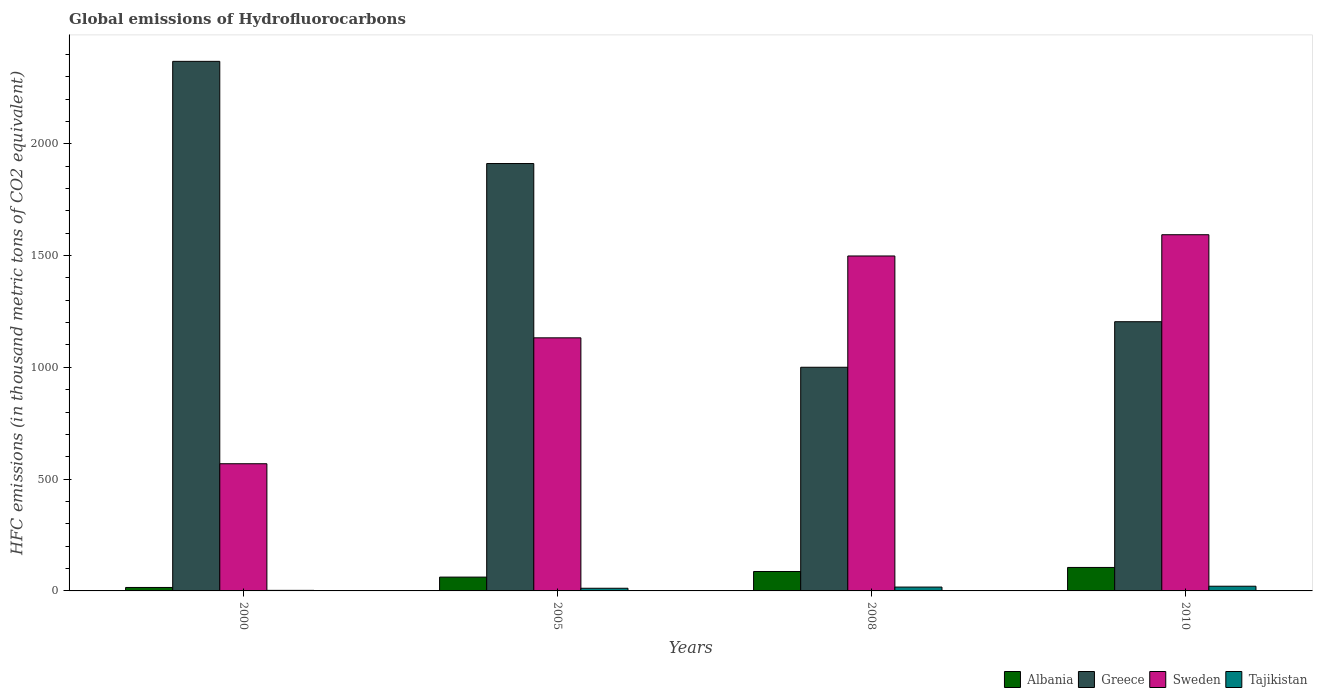Are the number of bars per tick equal to the number of legend labels?
Make the answer very short. Yes. How many bars are there on the 4th tick from the left?
Provide a succinct answer. 4. How many bars are there on the 3rd tick from the right?
Make the answer very short. 4. In how many cases, is the number of bars for a given year not equal to the number of legend labels?
Keep it short and to the point. 0. What is the global emissions of Hydrofluorocarbons in Greece in 2010?
Give a very brief answer. 1204. Across all years, what is the minimum global emissions of Hydrofluorocarbons in Albania?
Keep it short and to the point. 15.5. In which year was the global emissions of Hydrofluorocarbons in Greece maximum?
Your answer should be compact. 2000. In which year was the global emissions of Hydrofluorocarbons in Greece minimum?
Keep it short and to the point. 2008. What is the total global emissions of Hydrofluorocarbons in Greece in the graph?
Give a very brief answer. 6484.1. What is the difference between the global emissions of Hydrofluorocarbons in Albania in 2000 and that in 2005?
Offer a very short reply. -46.3. What is the difference between the global emissions of Hydrofluorocarbons in Greece in 2000 and the global emissions of Hydrofluorocarbons in Sweden in 2005?
Provide a short and direct response. 1236.5. What is the average global emissions of Hydrofluorocarbons in Tajikistan per year?
Give a very brief answer. 13.15. In the year 2000, what is the difference between the global emissions of Hydrofluorocarbons in Sweden and global emissions of Hydrofluorocarbons in Tajikistan?
Offer a terse response. 566.3. In how many years, is the global emissions of Hydrofluorocarbons in Tajikistan greater than 1100 thousand metric tons?
Ensure brevity in your answer.  0. What is the ratio of the global emissions of Hydrofluorocarbons in Albania in 2008 to that in 2010?
Give a very brief answer. 0.83. Is the global emissions of Hydrofluorocarbons in Greece in 2005 less than that in 2010?
Provide a short and direct response. No. What is the difference between the highest and the second highest global emissions of Hydrofluorocarbons in Sweden?
Your answer should be very brief. 95. What is the difference between the highest and the lowest global emissions of Hydrofluorocarbons in Greece?
Provide a short and direct response. 1368.1. Is the sum of the global emissions of Hydrofluorocarbons in Albania in 2005 and 2010 greater than the maximum global emissions of Hydrofluorocarbons in Tajikistan across all years?
Provide a succinct answer. Yes. What does the 4th bar from the left in 2005 represents?
Provide a succinct answer. Tajikistan. What does the 1st bar from the right in 2010 represents?
Your response must be concise. Tajikistan. Is it the case that in every year, the sum of the global emissions of Hydrofluorocarbons in Albania and global emissions of Hydrofluorocarbons in Tajikistan is greater than the global emissions of Hydrofluorocarbons in Greece?
Offer a very short reply. No. How many bars are there?
Keep it short and to the point. 16. Are all the bars in the graph horizontal?
Your answer should be compact. No. Are the values on the major ticks of Y-axis written in scientific E-notation?
Your response must be concise. No. Does the graph contain any zero values?
Ensure brevity in your answer.  No. Does the graph contain grids?
Give a very brief answer. No. Where does the legend appear in the graph?
Your answer should be compact. Bottom right. What is the title of the graph?
Provide a short and direct response. Global emissions of Hydrofluorocarbons. Does "Sao Tome and Principe" appear as one of the legend labels in the graph?
Give a very brief answer. No. What is the label or title of the Y-axis?
Your answer should be very brief. HFC emissions (in thousand metric tons of CO2 equivalent). What is the HFC emissions (in thousand metric tons of CO2 equivalent) in Greece in 2000?
Keep it short and to the point. 2368.4. What is the HFC emissions (in thousand metric tons of CO2 equivalent) of Sweden in 2000?
Offer a terse response. 568.8. What is the HFC emissions (in thousand metric tons of CO2 equivalent) in Albania in 2005?
Offer a very short reply. 61.8. What is the HFC emissions (in thousand metric tons of CO2 equivalent) of Greece in 2005?
Provide a succinct answer. 1911.4. What is the HFC emissions (in thousand metric tons of CO2 equivalent) of Sweden in 2005?
Your answer should be compact. 1131.9. What is the HFC emissions (in thousand metric tons of CO2 equivalent) in Albania in 2008?
Offer a very short reply. 86.9. What is the HFC emissions (in thousand metric tons of CO2 equivalent) of Greece in 2008?
Provide a succinct answer. 1000.3. What is the HFC emissions (in thousand metric tons of CO2 equivalent) in Sweden in 2008?
Your response must be concise. 1498. What is the HFC emissions (in thousand metric tons of CO2 equivalent) of Albania in 2010?
Provide a short and direct response. 105. What is the HFC emissions (in thousand metric tons of CO2 equivalent) in Greece in 2010?
Your answer should be compact. 1204. What is the HFC emissions (in thousand metric tons of CO2 equivalent) in Sweden in 2010?
Your answer should be compact. 1593. Across all years, what is the maximum HFC emissions (in thousand metric tons of CO2 equivalent) in Albania?
Provide a succinct answer. 105. Across all years, what is the maximum HFC emissions (in thousand metric tons of CO2 equivalent) of Greece?
Provide a succinct answer. 2368.4. Across all years, what is the maximum HFC emissions (in thousand metric tons of CO2 equivalent) of Sweden?
Keep it short and to the point. 1593. Across all years, what is the minimum HFC emissions (in thousand metric tons of CO2 equivalent) of Albania?
Make the answer very short. 15.5. Across all years, what is the minimum HFC emissions (in thousand metric tons of CO2 equivalent) of Greece?
Make the answer very short. 1000.3. Across all years, what is the minimum HFC emissions (in thousand metric tons of CO2 equivalent) in Sweden?
Give a very brief answer. 568.8. Across all years, what is the minimum HFC emissions (in thousand metric tons of CO2 equivalent) of Tajikistan?
Ensure brevity in your answer.  2.5. What is the total HFC emissions (in thousand metric tons of CO2 equivalent) in Albania in the graph?
Provide a short and direct response. 269.2. What is the total HFC emissions (in thousand metric tons of CO2 equivalent) in Greece in the graph?
Your answer should be compact. 6484.1. What is the total HFC emissions (in thousand metric tons of CO2 equivalent) of Sweden in the graph?
Offer a terse response. 4791.7. What is the total HFC emissions (in thousand metric tons of CO2 equivalent) of Tajikistan in the graph?
Provide a short and direct response. 52.6. What is the difference between the HFC emissions (in thousand metric tons of CO2 equivalent) in Albania in 2000 and that in 2005?
Make the answer very short. -46.3. What is the difference between the HFC emissions (in thousand metric tons of CO2 equivalent) of Greece in 2000 and that in 2005?
Your response must be concise. 457. What is the difference between the HFC emissions (in thousand metric tons of CO2 equivalent) in Sweden in 2000 and that in 2005?
Your answer should be very brief. -563.1. What is the difference between the HFC emissions (in thousand metric tons of CO2 equivalent) of Tajikistan in 2000 and that in 2005?
Provide a succinct answer. -9.4. What is the difference between the HFC emissions (in thousand metric tons of CO2 equivalent) of Albania in 2000 and that in 2008?
Make the answer very short. -71.4. What is the difference between the HFC emissions (in thousand metric tons of CO2 equivalent) in Greece in 2000 and that in 2008?
Make the answer very short. 1368.1. What is the difference between the HFC emissions (in thousand metric tons of CO2 equivalent) of Sweden in 2000 and that in 2008?
Offer a terse response. -929.2. What is the difference between the HFC emissions (in thousand metric tons of CO2 equivalent) of Tajikistan in 2000 and that in 2008?
Offer a very short reply. -14.7. What is the difference between the HFC emissions (in thousand metric tons of CO2 equivalent) of Albania in 2000 and that in 2010?
Offer a terse response. -89.5. What is the difference between the HFC emissions (in thousand metric tons of CO2 equivalent) in Greece in 2000 and that in 2010?
Your answer should be compact. 1164.4. What is the difference between the HFC emissions (in thousand metric tons of CO2 equivalent) in Sweden in 2000 and that in 2010?
Give a very brief answer. -1024.2. What is the difference between the HFC emissions (in thousand metric tons of CO2 equivalent) of Tajikistan in 2000 and that in 2010?
Offer a very short reply. -18.5. What is the difference between the HFC emissions (in thousand metric tons of CO2 equivalent) in Albania in 2005 and that in 2008?
Your answer should be very brief. -25.1. What is the difference between the HFC emissions (in thousand metric tons of CO2 equivalent) of Greece in 2005 and that in 2008?
Make the answer very short. 911.1. What is the difference between the HFC emissions (in thousand metric tons of CO2 equivalent) of Sweden in 2005 and that in 2008?
Make the answer very short. -366.1. What is the difference between the HFC emissions (in thousand metric tons of CO2 equivalent) in Tajikistan in 2005 and that in 2008?
Provide a succinct answer. -5.3. What is the difference between the HFC emissions (in thousand metric tons of CO2 equivalent) of Albania in 2005 and that in 2010?
Offer a terse response. -43.2. What is the difference between the HFC emissions (in thousand metric tons of CO2 equivalent) of Greece in 2005 and that in 2010?
Ensure brevity in your answer.  707.4. What is the difference between the HFC emissions (in thousand metric tons of CO2 equivalent) in Sweden in 2005 and that in 2010?
Your response must be concise. -461.1. What is the difference between the HFC emissions (in thousand metric tons of CO2 equivalent) of Albania in 2008 and that in 2010?
Offer a very short reply. -18.1. What is the difference between the HFC emissions (in thousand metric tons of CO2 equivalent) in Greece in 2008 and that in 2010?
Give a very brief answer. -203.7. What is the difference between the HFC emissions (in thousand metric tons of CO2 equivalent) in Sweden in 2008 and that in 2010?
Ensure brevity in your answer.  -95. What is the difference between the HFC emissions (in thousand metric tons of CO2 equivalent) of Albania in 2000 and the HFC emissions (in thousand metric tons of CO2 equivalent) of Greece in 2005?
Ensure brevity in your answer.  -1895.9. What is the difference between the HFC emissions (in thousand metric tons of CO2 equivalent) in Albania in 2000 and the HFC emissions (in thousand metric tons of CO2 equivalent) in Sweden in 2005?
Your answer should be compact. -1116.4. What is the difference between the HFC emissions (in thousand metric tons of CO2 equivalent) in Greece in 2000 and the HFC emissions (in thousand metric tons of CO2 equivalent) in Sweden in 2005?
Make the answer very short. 1236.5. What is the difference between the HFC emissions (in thousand metric tons of CO2 equivalent) of Greece in 2000 and the HFC emissions (in thousand metric tons of CO2 equivalent) of Tajikistan in 2005?
Provide a succinct answer. 2356.5. What is the difference between the HFC emissions (in thousand metric tons of CO2 equivalent) in Sweden in 2000 and the HFC emissions (in thousand metric tons of CO2 equivalent) in Tajikistan in 2005?
Offer a very short reply. 556.9. What is the difference between the HFC emissions (in thousand metric tons of CO2 equivalent) of Albania in 2000 and the HFC emissions (in thousand metric tons of CO2 equivalent) of Greece in 2008?
Your answer should be very brief. -984.8. What is the difference between the HFC emissions (in thousand metric tons of CO2 equivalent) in Albania in 2000 and the HFC emissions (in thousand metric tons of CO2 equivalent) in Sweden in 2008?
Provide a succinct answer. -1482.5. What is the difference between the HFC emissions (in thousand metric tons of CO2 equivalent) of Albania in 2000 and the HFC emissions (in thousand metric tons of CO2 equivalent) of Tajikistan in 2008?
Offer a terse response. -1.7. What is the difference between the HFC emissions (in thousand metric tons of CO2 equivalent) in Greece in 2000 and the HFC emissions (in thousand metric tons of CO2 equivalent) in Sweden in 2008?
Keep it short and to the point. 870.4. What is the difference between the HFC emissions (in thousand metric tons of CO2 equivalent) in Greece in 2000 and the HFC emissions (in thousand metric tons of CO2 equivalent) in Tajikistan in 2008?
Provide a short and direct response. 2351.2. What is the difference between the HFC emissions (in thousand metric tons of CO2 equivalent) in Sweden in 2000 and the HFC emissions (in thousand metric tons of CO2 equivalent) in Tajikistan in 2008?
Provide a succinct answer. 551.6. What is the difference between the HFC emissions (in thousand metric tons of CO2 equivalent) of Albania in 2000 and the HFC emissions (in thousand metric tons of CO2 equivalent) of Greece in 2010?
Your answer should be compact. -1188.5. What is the difference between the HFC emissions (in thousand metric tons of CO2 equivalent) of Albania in 2000 and the HFC emissions (in thousand metric tons of CO2 equivalent) of Sweden in 2010?
Your answer should be very brief. -1577.5. What is the difference between the HFC emissions (in thousand metric tons of CO2 equivalent) in Greece in 2000 and the HFC emissions (in thousand metric tons of CO2 equivalent) in Sweden in 2010?
Your answer should be compact. 775.4. What is the difference between the HFC emissions (in thousand metric tons of CO2 equivalent) of Greece in 2000 and the HFC emissions (in thousand metric tons of CO2 equivalent) of Tajikistan in 2010?
Offer a very short reply. 2347.4. What is the difference between the HFC emissions (in thousand metric tons of CO2 equivalent) in Sweden in 2000 and the HFC emissions (in thousand metric tons of CO2 equivalent) in Tajikistan in 2010?
Offer a very short reply. 547.8. What is the difference between the HFC emissions (in thousand metric tons of CO2 equivalent) of Albania in 2005 and the HFC emissions (in thousand metric tons of CO2 equivalent) of Greece in 2008?
Your answer should be compact. -938.5. What is the difference between the HFC emissions (in thousand metric tons of CO2 equivalent) in Albania in 2005 and the HFC emissions (in thousand metric tons of CO2 equivalent) in Sweden in 2008?
Offer a very short reply. -1436.2. What is the difference between the HFC emissions (in thousand metric tons of CO2 equivalent) of Albania in 2005 and the HFC emissions (in thousand metric tons of CO2 equivalent) of Tajikistan in 2008?
Give a very brief answer. 44.6. What is the difference between the HFC emissions (in thousand metric tons of CO2 equivalent) in Greece in 2005 and the HFC emissions (in thousand metric tons of CO2 equivalent) in Sweden in 2008?
Ensure brevity in your answer.  413.4. What is the difference between the HFC emissions (in thousand metric tons of CO2 equivalent) of Greece in 2005 and the HFC emissions (in thousand metric tons of CO2 equivalent) of Tajikistan in 2008?
Ensure brevity in your answer.  1894.2. What is the difference between the HFC emissions (in thousand metric tons of CO2 equivalent) of Sweden in 2005 and the HFC emissions (in thousand metric tons of CO2 equivalent) of Tajikistan in 2008?
Your answer should be very brief. 1114.7. What is the difference between the HFC emissions (in thousand metric tons of CO2 equivalent) in Albania in 2005 and the HFC emissions (in thousand metric tons of CO2 equivalent) in Greece in 2010?
Your answer should be compact. -1142.2. What is the difference between the HFC emissions (in thousand metric tons of CO2 equivalent) in Albania in 2005 and the HFC emissions (in thousand metric tons of CO2 equivalent) in Sweden in 2010?
Provide a succinct answer. -1531.2. What is the difference between the HFC emissions (in thousand metric tons of CO2 equivalent) of Albania in 2005 and the HFC emissions (in thousand metric tons of CO2 equivalent) of Tajikistan in 2010?
Offer a very short reply. 40.8. What is the difference between the HFC emissions (in thousand metric tons of CO2 equivalent) of Greece in 2005 and the HFC emissions (in thousand metric tons of CO2 equivalent) of Sweden in 2010?
Provide a succinct answer. 318.4. What is the difference between the HFC emissions (in thousand metric tons of CO2 equivalent) of Greece in 2005 and the HFC emissions (in thousand metric tons of CO2 equivalent) of Tajikistan in 2010?
Offer a very short reply. 1890.4. What is the difference between the HFC emissions (in thousand metric tons of CO2 equivalent) of Sweden in 2005 and the HFC emissions (in thousand metric tons of CO2 equivalent) of Tajikistan in 2010?
Your answer should be compact. 1110.9. What is the difference between the HFC emissions (in thousand metric tons of CO2 equivalent) of Albania in 2008 and the HFC emissions (in thousand metric tons of CO2 equivalent) of Greece in 2010?
Ensure brevity in your answer.  -1117.1. What is the difference between the HFC emissions (in thousand metric tons of CO2 equivalent) of Albania in 2008 and the HFC emissions (in thousand metric tons of CO2 equivalent) of Sweden in 2010?
Give a very brief answer. -1506.1. What is the difference between the HFC emissions (in thousand metric tons of CO2 equivalent) of Albania in 2008 and the HFC emissions (in thousand metric tons of CO2 equivalent) of Tajikistan in 2010?
Make the answer very short. 65.9. What is the difference between the HFC emissions (in thousand metric tons of CO2 equivalent) in Greece in 2008 and the HFC emissions (in thousand metric tons of CO2 equivalent) in Sweden in 2010?
Offer a terse response. -592.7. What is the difference between the HFC emissions (in thousand metric tons of CO2 equivalent) of Greece in 2008 and the HFC emissions (in thousand metric tons of CO2 equivalent) of Tajikistan in 2010?
Offer a terse response. 979.3. What is the difference between the HFC emissions (in thousand metric tons of CO2 equivalent) in Sweden in 2008 and the HFC emissions (in thousand metric tons of CO2 equivalent) in Tajikistan in 2010?
Ensure brevity in your answer.  1477. What is the average HFC emissions (in thousand metric tons of CO2 equivalent) of Albania per year?
Offer a terse response. 67.3. What is the average HFC emissions (in thousand metric tons of CO2 equivalent) in Greece per year?
Provide a succinct answer. 1621.03. What is the average HFC emissions (in thousand metric tons of CO2 equivalent) in Sweden per year?
Offer a terse response. 1197.92. What is the average HFC emissions (in thousand metric tons of CO2 equivalent) in Tajikistan per year?
Your response must be concise. 13.15. In the year 2000, what is the difference between the HFC emissions (in thousand metric tons of CO2 equivalent) in Albania and HFC emissions (in thousand metric tons of CO2 equivalent) in Greece?
Your answer should be very brief. -2352.9. In the year 2000, what is the difference between the HFC emissions (in thousand metric tons of CO2 equivalent) of Albania and HFC emissions (in thousand metric tons of CO2 equivalent) of Sweden?
Offer a terse response. -553.3. In the year 2000, what is the difference between the HFC emissions (in thousand metric tons of CO2 equivalent) of Albania and HFC emissions (in thousand metric tons of CO2 equivalent) of Tajikistan?
Your answer should be very brief. 13. In the year 2000, what is the difference between the HFC emissions (in thousand metric tons of CO2 equivalent) of Greece and HFC emissions (in thousand metric tons of CO2 equivalent) of Sweden?
Offer a terse response. 1799.6. In the year 2000, what is the difference between the HFC emissions (in thousand metric tons of CO2 equivalent) in Greece and HFC emissions (in thousand metric tons of CO2 equivalent) in Tajikistan?
Offer a very short reply. 2365.9. In the year 2000, what is the difference between the HFC emissions (in thousand metric tons of CO2 equivalent) of Sweden and HFC emissions (in thousand metric tons of CO2 equivalent) of Tajikistan?
Your answer should be very brief. 566.3. In the year 2005, what is the difference between the HFC emissions (in thousand metric tons of CO2 equivalent) of Albania and HFC emissions (in thousand metric tons of CO2 equivalent) of Greece?
Your answer should be very brief. -1849.6. In the year 2005, what is the difference between the HFC emissions (in thousand metric tons of CO2 equivalent) in Albania and HFC emissions (in thousand metric tons of CO2 equivalent) in Sweden?
Make the answer very short. -1070.1. In the year 2005, what is the difference between the HFC emissions (in thousand metric tons of CO2 equivalent) of Albania and HFC emissions (in thousand metric tons of CO2 equivalent) of Tajikistan?
Your answer should be very brief. 49.9. In the year 2005, what is the difference between the HFC emissions (in thousand metric tons of CO2 equivalent) in Greece and HFC emissions (in thousand metric tons of CO2 equivalent) in Sweden?
Provide a short and direct response. 779.5. In the year 2005, what is the difference between the HFC emissions (in thousand metric tons of CO2 equivalent) in Greece and HFC emissions (in thousand metric tons of CO2 equivalent) in Tajikistan?
Give a very brief answer. 1899.5. In the year 2005, what is the difference between the HFC emissions (in thousand metric tons of CO2 equivalent) in Sweden and HFC emissions (in thousand metric tons of CO2 equivalent) in Tajikistan?
Keep it short and to the point. 1120. In the year 2008, what is the difference between the HFC emissions (in thousand metric tons of CO2 equivalent) in Albania and HFC emissions (in thousand metric tons of CO2 equivalent) in Greece?
Your answer should be very brief. -913.4. In the year 2008, what is the difference between the HFC emissions (in thousand metric tons of CO2 equivalent) of Albania and HFC emissions (in thousand metric tons of CO2 equivalent) of Sweden?
Your answer should be compact. -1411.1. In the year 2008, what is the difference between the HFC emissions (in thousand metric tons of CO2 equivalent) in Albania and HFC emissions (in thousand metric tons of CO2 equivalent) in Tajikistan?
Provide a short and direct response. 69.7. In the year 2008, what is the difference between the HFC emissions (in thousand metric tons of CO2 equivalent) of Greece and HFC emissions (in thousand metric tons of CO2 equivalent) of Sweden?
Give a very brief answer. -497.7. In the year 2008, what is the difference between the HFC emissions (in thousand metric tons of CO2 equivalent) in Greece and HFC emissions (in thousand metric tons of CO2 equivalent) in Tajikistan?
Your answer should be compact. 983.1. In the year 2008, what is the difference between the HFC emissions (in thousand metric tons of CO2 equivalent) of Sweden and HFC emissions (in thousand metric tons of CO2 equivalent) of Tajikistan?
Make the answer very short. 1480.8. In the year 2010, what is the difference between the HFC emissions (in thousand metric tons of CO2 equivalent) of Albania and HFC emissions (in thousand metric tons of CO2 equivalent) of Greece?
Keep it short and to the point. -1099. In the year 2010, what is the difference between the HFC emissions (in thousand metric tons of CO2 equivalent) of Albania and HFC emissions (in thousand metric tons of CO2 equivalent) of Sweden?
Keep it short and to the point. -1488. In the year 2010, what is the difference between the HFC emissions (in thousand metric tons of CO2 equivalent) in Greece and HFC emissions (in thousand metric tons of CO2 equivalent) in Sweden?
Make the answer very short. -389. In the year 2010, what is the difference between the HFC emissions (in thousand metric tons of CO2 equivalent) in Greece and HFC emissions (in thousand metric tons of CO2 equivalent) in Tajikistan?
Give a very brief answer. 1183. In the year 2010, what is the difference between the HFC emissions (in thousand metric tons of CO2 equivalent) in Sweden and HFC emissions (in thousand metric tons of CO2 equivalent) in Tajikistan?
Provide a short and direct response. 1572. What is the ratio of the HFC emissions (in thousand metric tons of CO2 equivalent) in Albania in 2000 to that in 2005?
Provide a short and direct response. 0.25. What is the ratio of the HFC emissions (in thousand metric tons of CO2 equivalent) in Greece in 2000 to that in 2005?
Your response must be concise. 1.24. What is the ratio of the HFC emissions (in thousand metric tons of CO2 equivalent) in Sweden in 2000 to that in 2005?
Your answer should be compact. 0.5. What is the ratio of the HFC emissions (in thousand metric tons of CO2 equivalent) of Tajikistan in 2000 to that in 2005?
Ensure brevity in your answer.  0.21. What is the ratio of the HFC emissions (in thousand metric tons of CO2 equivalent) in Albania in 2000 to that in 2008?
Make the answer very short. 0.18. What is the ratio of the HFC emissions (in thousand metric tons of CO2 equivalent) of Greece in 2000 to that in 2008?
Give a very brief answer. 2.37. What is the ratio of the HFC emissions (in thousand metric tons of CO2 equivalent) of Sweden in 2000 to that in 2008?
Offer a very short reply. 0.38. What is the ratio of the HFC emissions (in thousand metric tons of CO2 equivalent) of Tajikistan in 2000 to that in 2008?
Keep it short and to the point. 0.15. What is the ratio of the HFC emissions (in thousand metric tons of CO2 equivalent) in Albania in 2000 to that in 2010?
Ensure brevity in your answer.  0.15. What is the ratio of the HFC emissions (in thousand metric tons of CO2 equivalent) in Greece in 2000 to that in 2010?
Ensure brevity in your answer.  1.97. What is the ratio of the HFC emissions (in thousand metric tons of CO2 equivalent) of Sweden in 2000 to that in 2010?
Provide a short and direct response. 0.36. What is the ratio of the HFC emissions (in thousand metric tons of CO2 equivalent) in Tajikistan in 2000 to that in 2010?
Provide a succinct answer. 0.12. What is the ratio of the HFC emissions (in thousand metric tons of CO2 equivalent) in Albania in 2005 to that in 2008?
Offer a very short reply. 0.71. What is the ratio of the HFC emissions (in thousand metric tons of CO2 equivalent) in Greece in 2005 to that in 2008?
Give a very brief answer. 1.91. What is the ratio of the HFC emissions (in thousand metric tons of CO2 equivalent) of Sweden in 2005 to that in 2008?
Give a very brief answer. 0.76. What is the ratio of the HFC emissions (in thousand metric tons of CO2 equivalent) of Tajikistan in 2005 to that in 2008?
Give a very brief answer. 0.69. What is the ratio of the HFC emissions (in thousand metric tons of CO2 equivalent) in Albania in 2005 to that in 2010?
Keep it short and to the point. 0.59. What is the ratio of the HFC emissions (in thousand metric tons of CO2 equivalent) of Greece in 2005 to that in 2010?
Ensure brevity in your answer.  1.59. What is the ratio of the HFC emissions (in thousand metric tons of CO2 equivalent) in Sweden in 2005 to that in 2010?
Make the answer very short. 0.71. What is the ratio of the HFC emissions (in thousand metric tons of CO2 equivalent) of Tajikistan in 2005 to that in 2010?
Your response must be concise. 0.57. What is the ratio of the HFC emissions (in thousand metric tons of CO2 equivalent) of Albania in 2008 to that in 2010?
Offer a very short reply. 0.83. What is the ratio of the HFC emissions (in thousand metric tons of CO2 equivalent) of Greece in 2008 to that in 2010?
Make the answer very short. 0.83. What is the ratio of the HFC emissions (in thousand metric tons of CO2 equivalent) in Sweden in 2008 to that in 2010?
Ensure brevity in your answer.  0.94. What is the ratio of the HFC emissions (in thousand metric tons of CO2 equivalent) of Tajikistan in 2008 to that in 2010?
Offer a very short reply. 0.82. What is the difference between the highest and the second highest HFC emissions (in thousand metric tons of CO2 equivalent) in Greece?
Provide a short and direct response. 457. What is the difference between the highest and the second highest HFC emissions (in thousand metric tons of CO2 equivalent) in Sweden?
Provide a succinct answer. 95. What is the difference between the highest and the second highest HFC emissions (in thousand metric tons of CO2 equivalent) in Tajikistan?
Provide a short and direct response. 3.8. What is the difference between the highest and the lowest HFC emissions (in thousand metric tons of CO2 equivalent) in Albania?
Your answer should be very brief. 89.5. What is the difference between the highest and the lowest HFC emissions (in thousand metric tons of CO2 equivalent) in Greece?
Offer a terse response. 1368.1. What is the difference between the highest and the lowest HFC emissions (in thousand metric tons of CO2 equivalent) in Sweden?
Your answer should be compact. 1024.2. What is the difference between the highest and the lowest HFC emissions (in thousand metric tons of CO2 equivalent) of Tajikistan?
Offer a terse response. 18.5. 